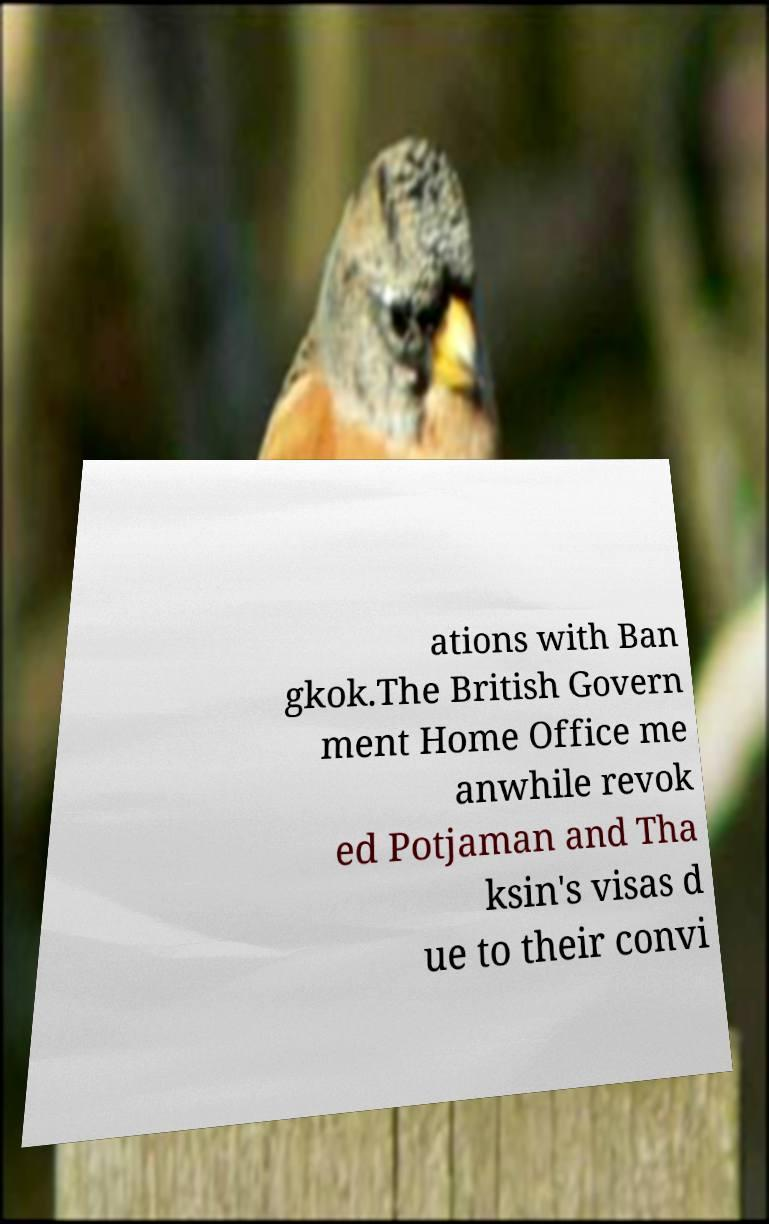Please read and relay the text visible in this image. What does it say? ations with Ban gkok.The British Govern ment Home Office me anwhile revok ed Potjaman and Tha ksin's visas d ue to their convi 